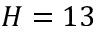Convert formula to latex. <formula><loc_0><loc_0><loc_500><loc_500>H = 1 3</formula> 